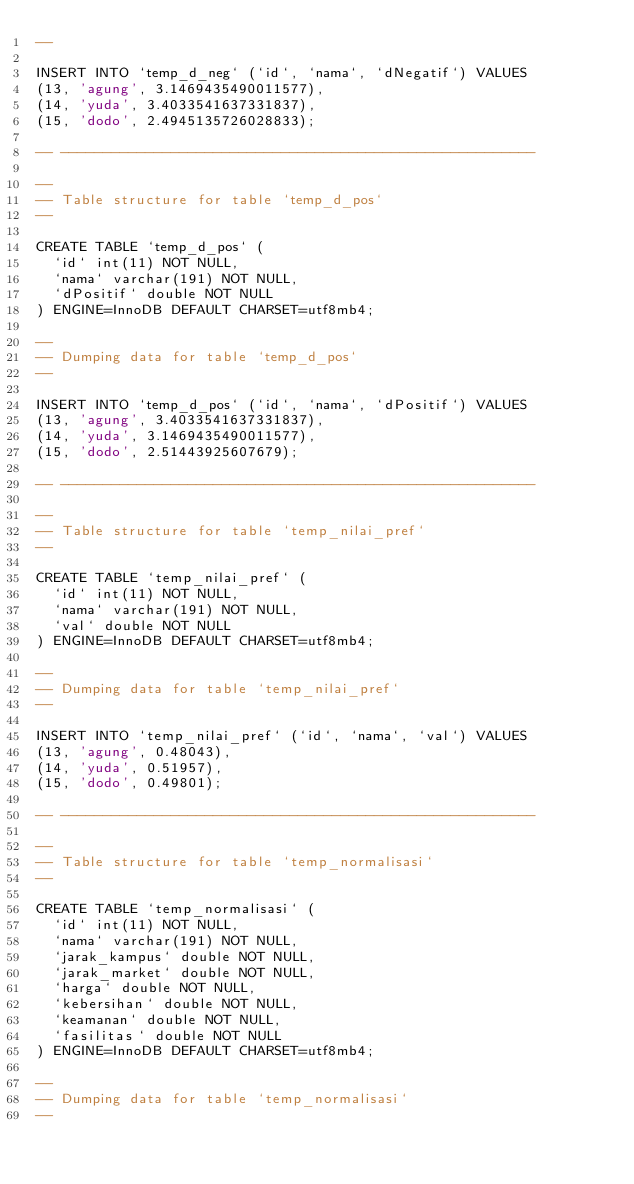<code> <loc_0><loc_0><loc_500><loc_500><_SQL_>--

INSERT INTO `temp_d_neg` (`id`, `nama`, `dNegatif`) VALUES
(13, 'agung', 3.1469435490011577),
(14, 'yuda', 3.4033541637331837),
(15, 'dodo', 2.4945135726028833);

-- --------------------------------------------------------

--
-- Table structure for table `temp_d_pos`
--

CREATE TABLE `temp_d_pos` (
  `id` int(11) NOT NULL,
  `nama` varchar(191) NOT NULL,
  `dPositif` double NOT NULL
) ENGINE=InnoDB DEFAULT CHARSET=utf8mb4;

--
-- Dumping data for table `temp_d_pos`
--

INSERT INTO `temp_d_pos` (`id`, `nama`, `dPositif`) VALUES
(13, 'agung', 3.4033541637331837),
(14, 'yuda', 3.1469435490011577),
(15, 'dodo', 2.51443925607679);

-- --------------------------------------------------------

--
-- Table structure for table `temp_nilai_pref`
--

CREATE TABLE `temp_nilai_pref` (
  `id` int(11) NOT NULL,
  `nama` varchar(191) NOT NULL,
  `val` double NOT NULL
) ENGINE=InnoDB DEFAULT CHARSET=utf8mb4;

--
-- Dumping data for table `temp_nilai_pref`
--

INSERT INTO `temp_nilai_pref` (`id`, `nama`, `val`) VALUES
(13, 'agung', 0.48043),
(14, 'yuda', 0.51957),
(15, 'dodo', 0.49801);

-- --------------------------------------------------------

--
-- Table structure for table `temp_normalisasi`
--

CREATE TABLE `temp_normalisasi` (
  `id` int(11) NOT NULL,
  `nama` varchar(191) NOT NULL,
  `jarak_kampus` double NOT NULL,
  `jarak_market` double NOT NULL,
  `harga` double NOT NULL,
  `kebersihan` double NOT NULL,
  `keamanan` double NOT NULL,
  `fasilitas` double NOT NULL
) ENGINE=InnoDB DEFAULT CHARSET=utf8mb4;

--
-- Dumping data for table `temp_normalisasi`
--
</code> 